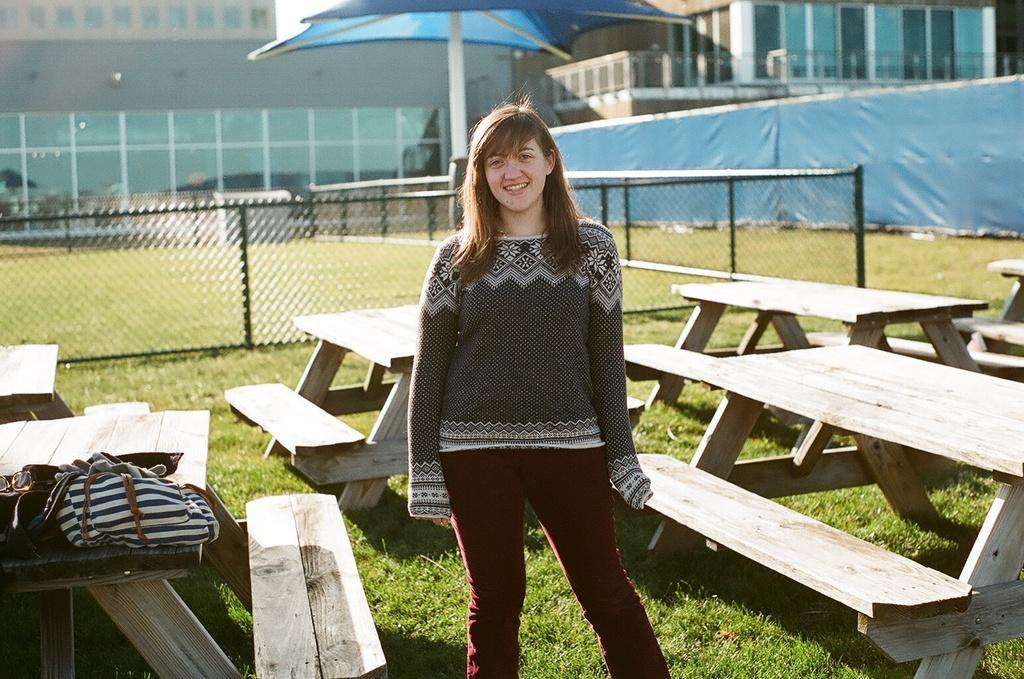Could you give a brief overview of what you see in this image? In this image there is woman standing in the ground. There are many benches in the ground, beside the women there is a bag on the bench. At the background there is a fencing,and a building, in this image i can see an umbrella in the ground, on the ground i can see a grass. 